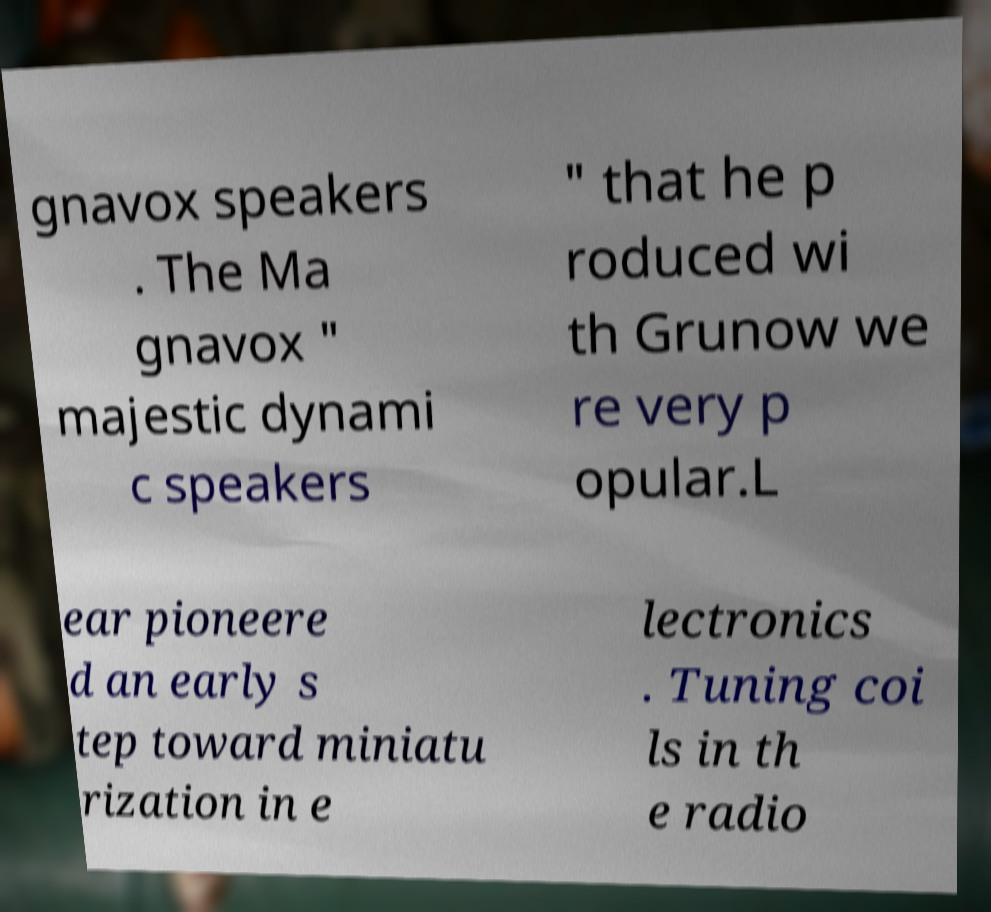Please read and relay the text visible in this image. What does it say? gnavox speakers . The Ma gnavox " majestic dynami c speakers " that he p roduced wi th Grunow we re very p opular.L ear pioneere d an early s tep toward miniatu rization in e lectronics . Tuning coi ls in th e radio 